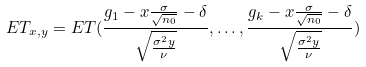Convert formula to latex. <formula><loc_0><loc_0><loc_500><loc_500>E T _ { x , y } = E T ( \frac { g _ { 1 } - x \frac { \sigma } { \sqrt { n _ { 0 } } } - \delta } { \sqrt { \frac { \sigma ^ { 2 } y } { \nu } } } , \dots , \frac { g _ { k } - x \frac { \sigma } { \sqrt { n _ { 0 } } } - \delta } { \sqrt { \frac { \sigma ^ { 2 } y } { \nu } } } )</formula> 